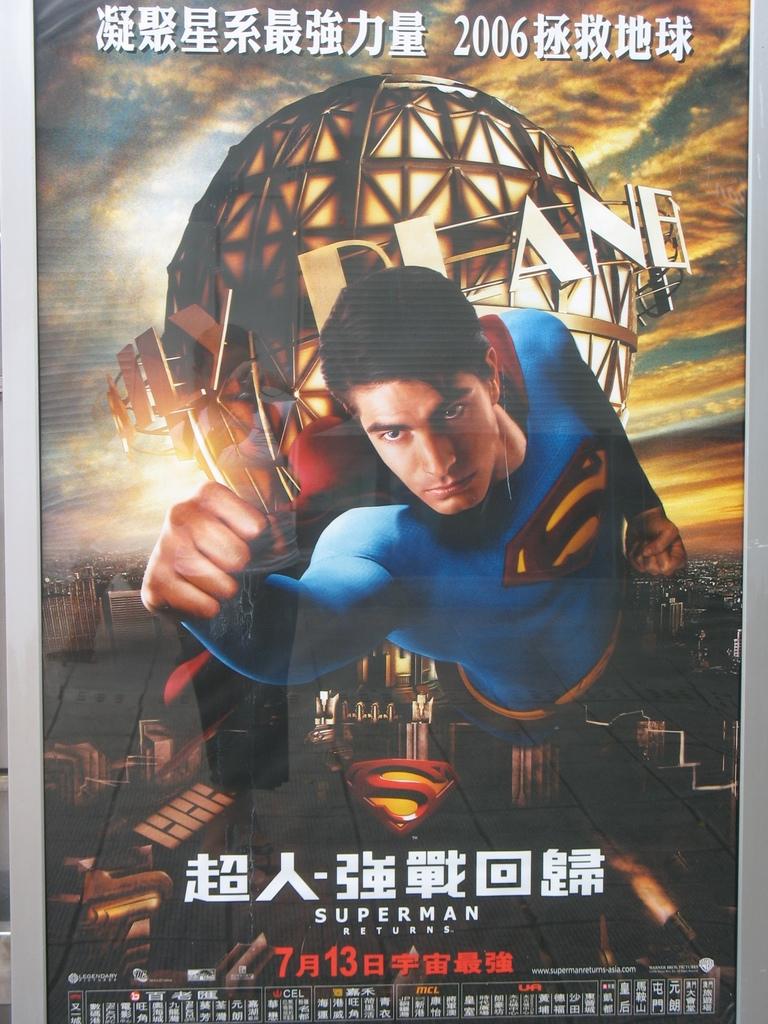What is the name of the character shown?
Your answer should be very brief. Superman. What does the red text say?
Your response must be concise. Unanswerable. 